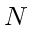Convert formula to latex. <formula><loc_0><loc_0><loc_500><loc_500>N</formula> 